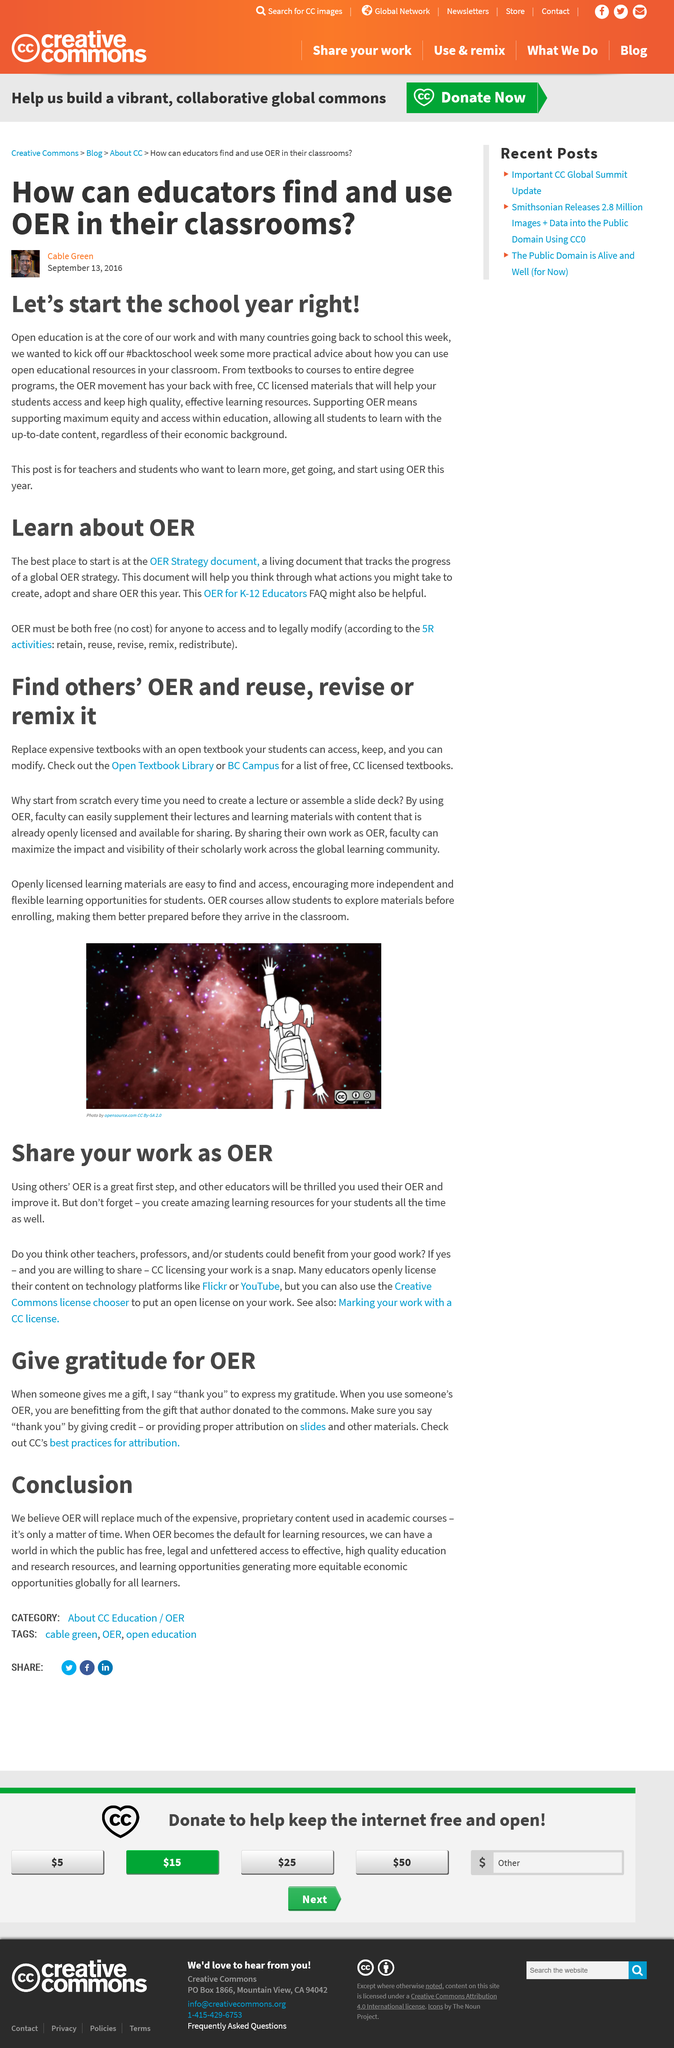Identify some key points in this picture. This article was made on September 13, 2016. The article is titled "How can educators find and use OER in their classrooms?". A CC licence is a permit issued by Creative Commons that allows the use of copyrighted material under specific conditions. Using others' OER is a tremendous first step towards achieving great success in any project or endeavor. Declarative: Maximizing the impact and visibility of scholarly work across the global learning community is achieved through the sharing of work as OER. 